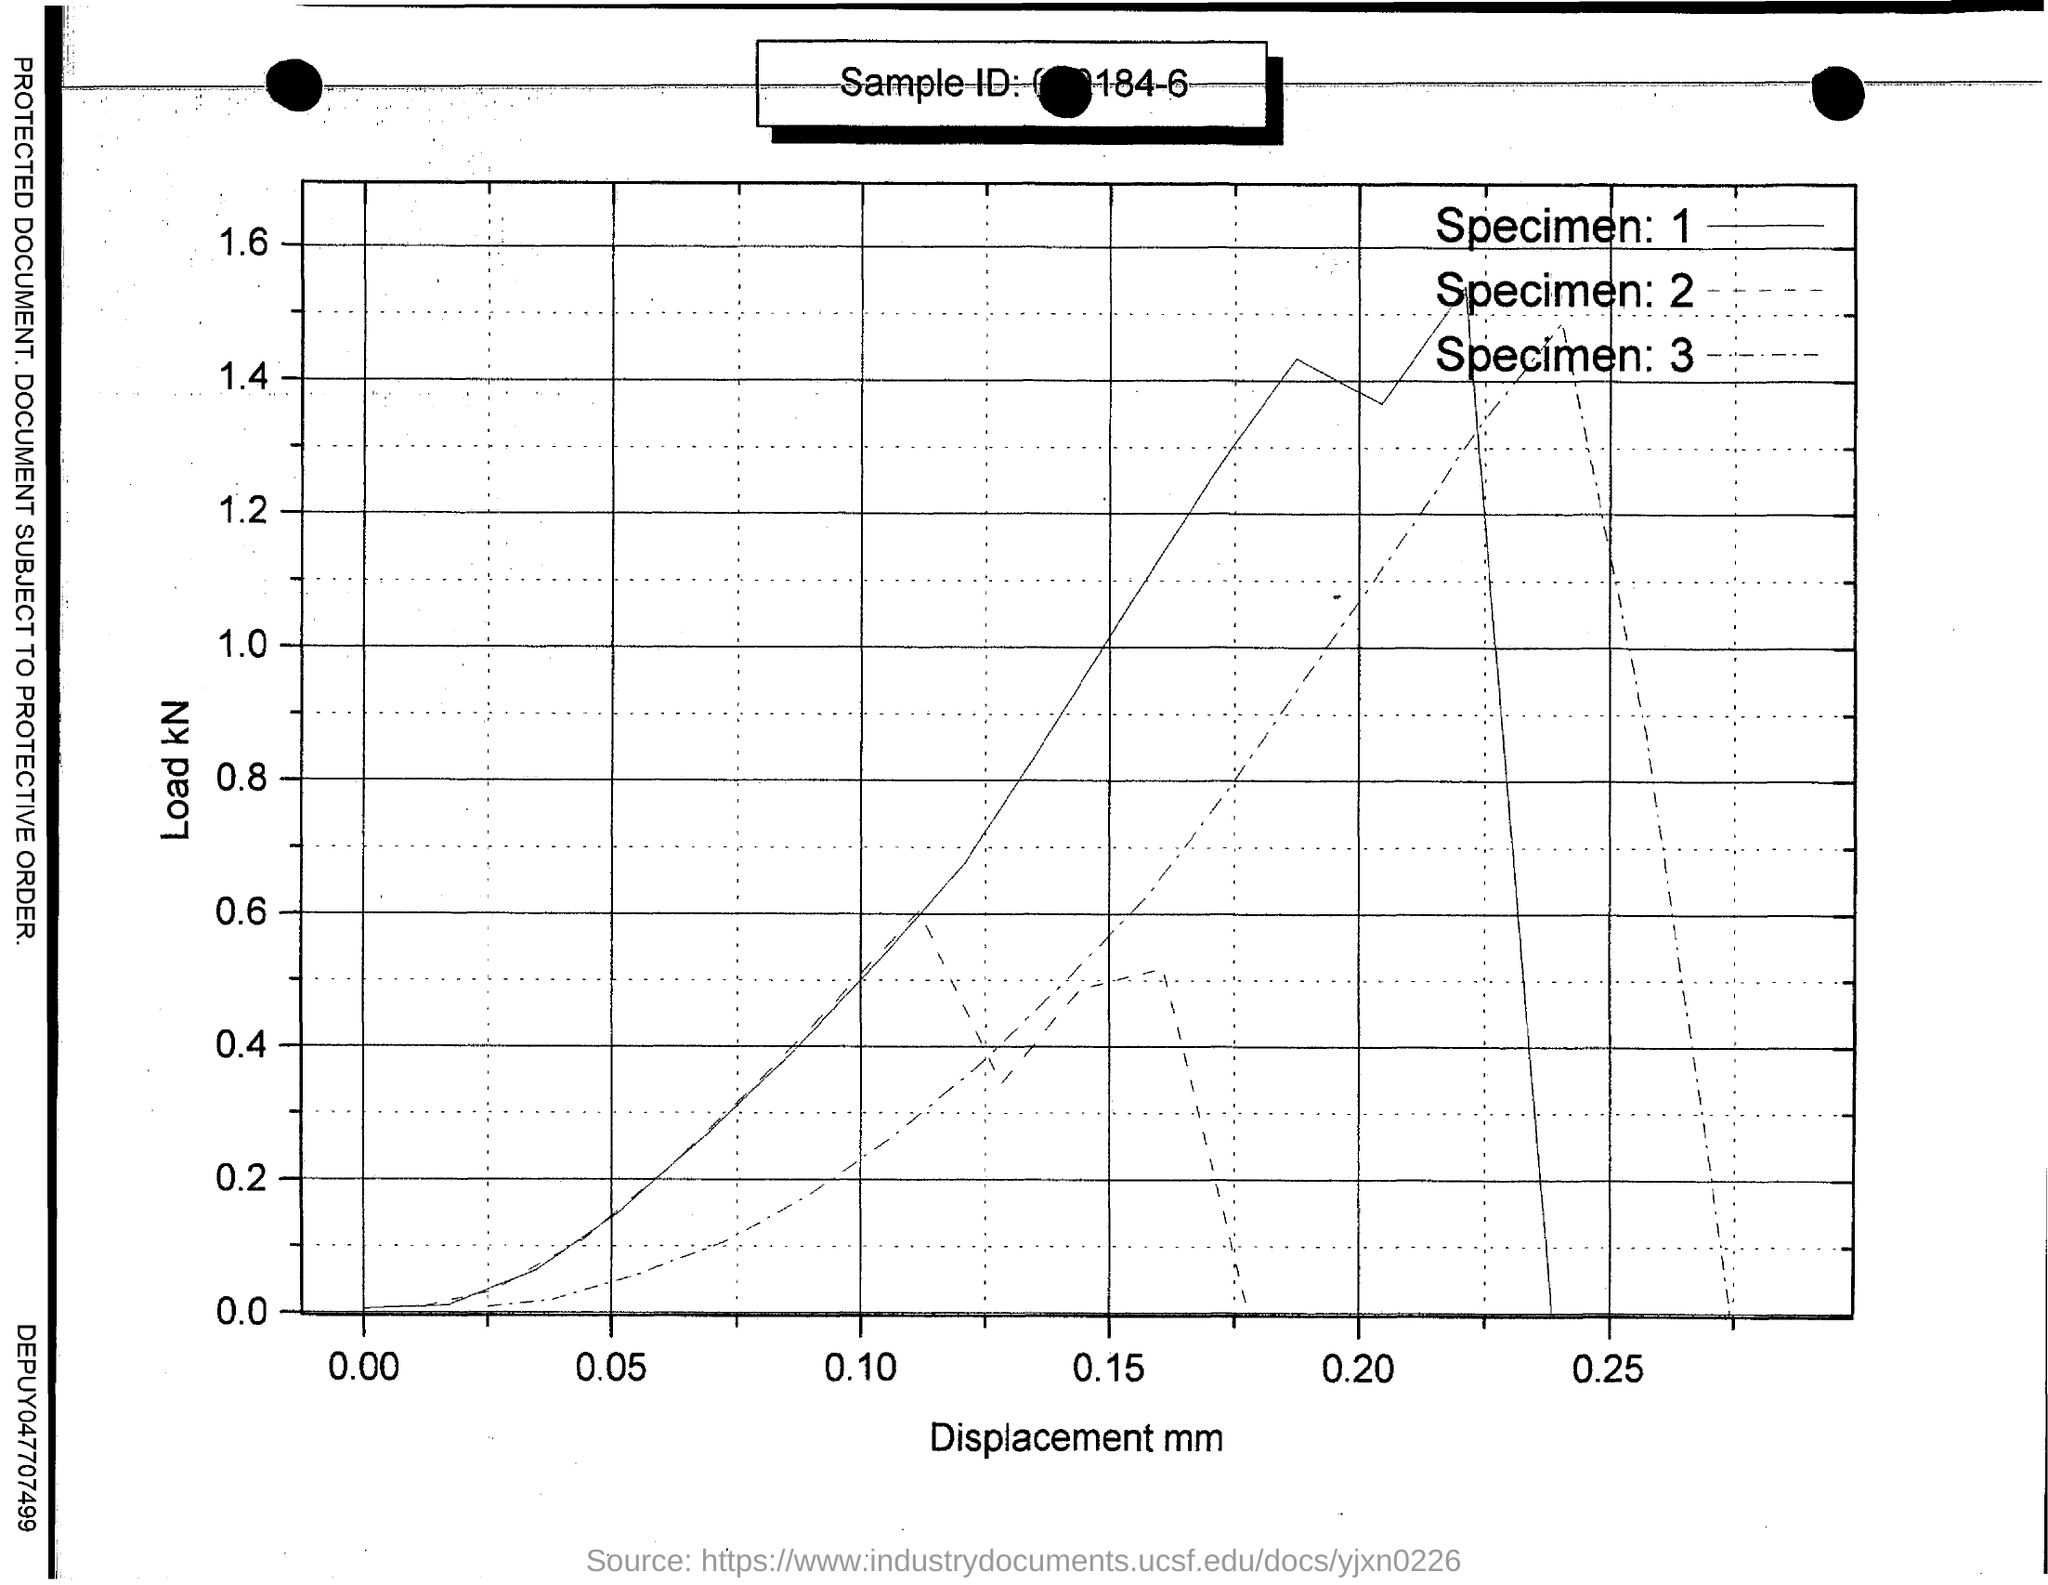Identify some key points in this picture. The x-axis in the graph shows the displacement of the object versus time. The load in the y-axis is plotted in the graph. 